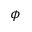Convert formula to latex. <formula><loc_0><loc_0><loc_500><loc_500>\phi</formula> 